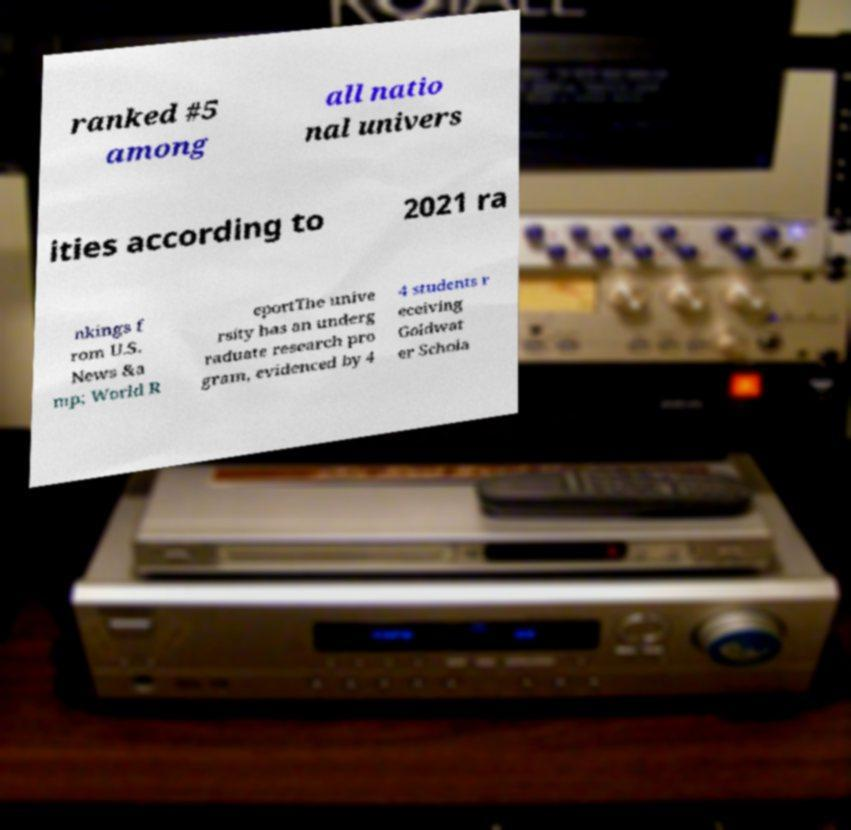There's text embedded in this image that I need extracted. Can you transcribe it verbatim? ranked #5 among all natio nal univers ities according to 2021 ra nkings f rom U.S. News &a mp; World R eportThe unive rsity has an underg raduate research pro gram, evidenced by 4 4 students r eceiving Goldwat er Schola 